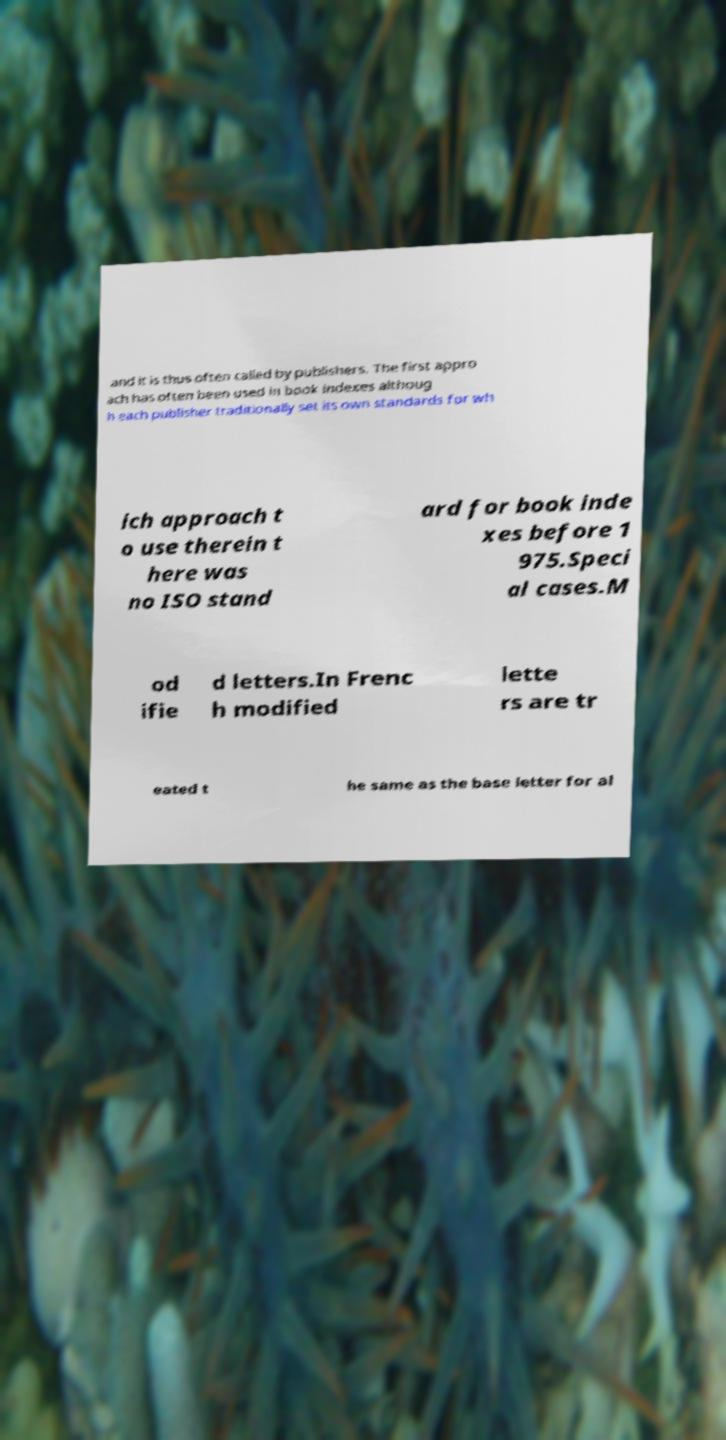For documentation purposes, I need the text within this image transcribed. Could you provide that? and it is thus often called by publishers. The first appro ach has often been used in book indexes althoug h each publisher traditionally set its own standards for wh ich approach t o use therein t here was no ISO stand ard for book inde xes before 1 975.Speci al cases.M od ifie d letters.In Frenc h modified lette rs are tr eated t he same as the base letter for al 